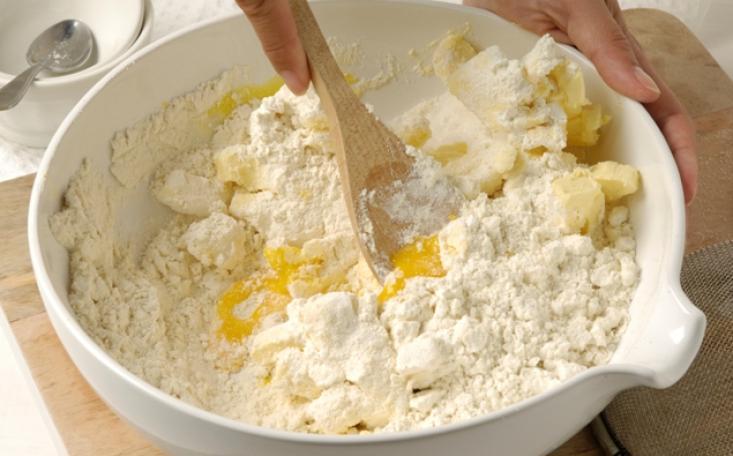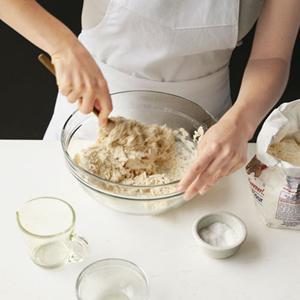The first image is the image on the left, the second image is the image on the right. For the images displayed, is the sentence "Each image shows a utensil in a bowl of food mixture, and one image shows one hand stirring with the utensil as the other hand holds the edge of the bowl." factually correct? Answer yes or no. Yes. 